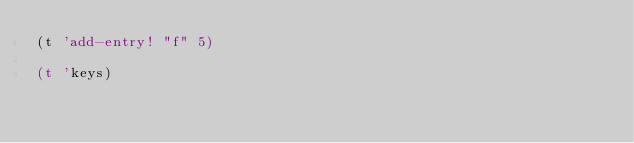<code> <loc_0><loc_0><loc_500><loc_500><_Scheme_>(t 'add-entry! "f" 5)

(t 'keys)
</code> 